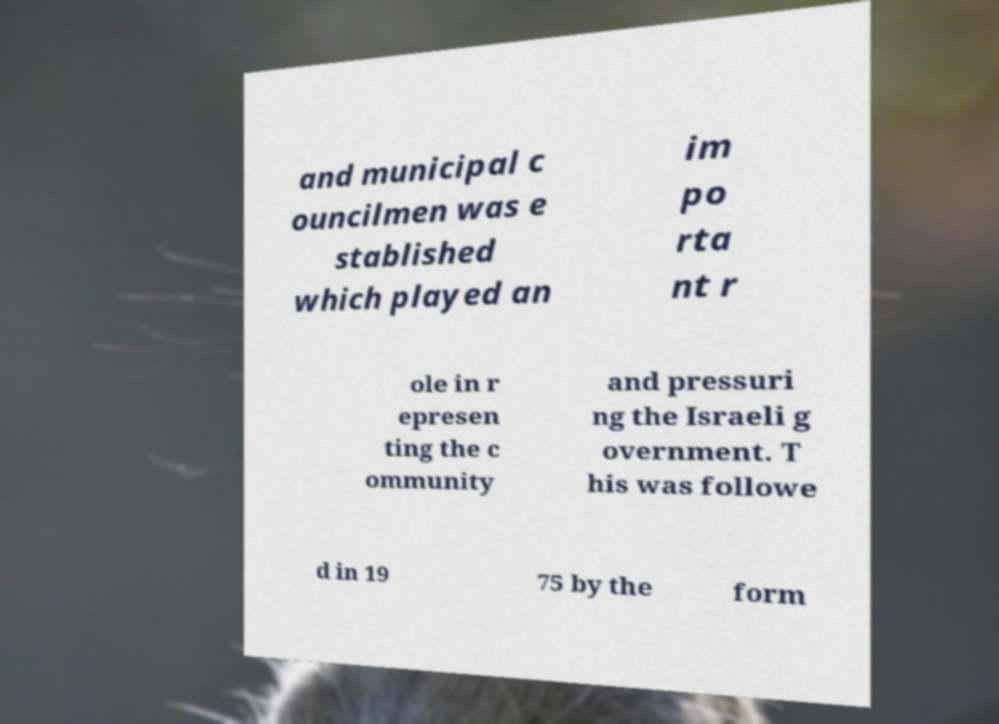Please read and relay the text visible in this image. What does it say? and municipal c ouncilmen was e stablished which played an im po rta nt r ole in r epresen ting the c ommunity and pressuri ng the Israeli g overnment. T his was followe d in 19 75 by the form 